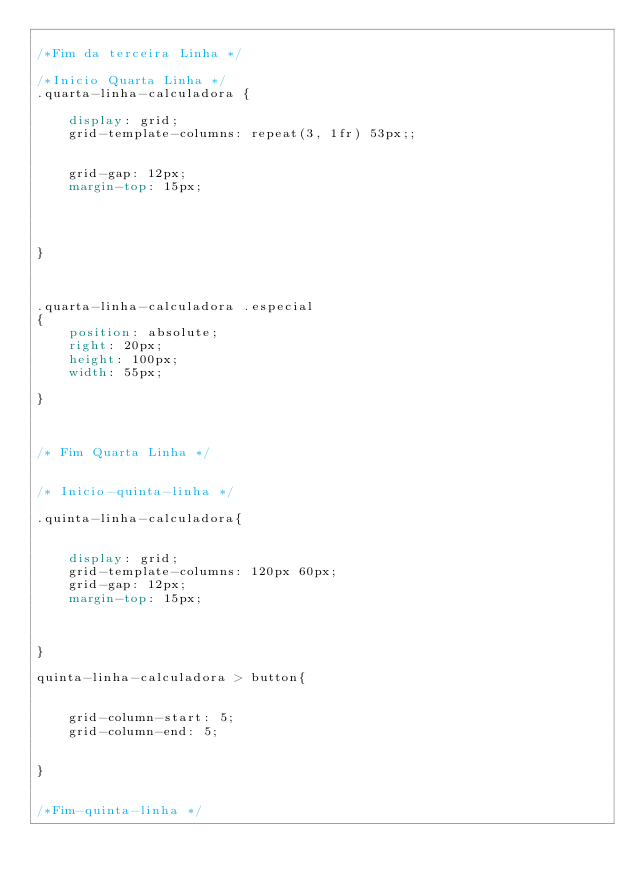<code> <loc_0><loc_0><loc_500><loc_500><_CSS_>
/*Fim da terceira Linha */ 

/*Inicio Quarta Linha */ 
.quarta-linha-calculadora { 

    display: grid; 
    grid-template-columns: repeat(3, 1fr) 53px;; 
     
     
    grid-gap: 12px; 
    margin-top: 15px;    




}



.quarta-linha-calculadora .especial 
{
    position: absolute;     
    right: 20px; 
    height: 100px; 
    width: 55px;

}



/* Fim Quarta Linha */ 


/* Inicio-quinta-linha */

.quinta-linha-calculadora{


    display: grid; 
    grid-template-columns: 120px 60px;   
    grid-gap: 12px; 
    margin-top: 15px;



}

quinta-linha-calculadora > button{


    grid-column-start: 5;
    grid-column-end: 5; 


}


/*Fim-quinta-linha */ 
</code> 